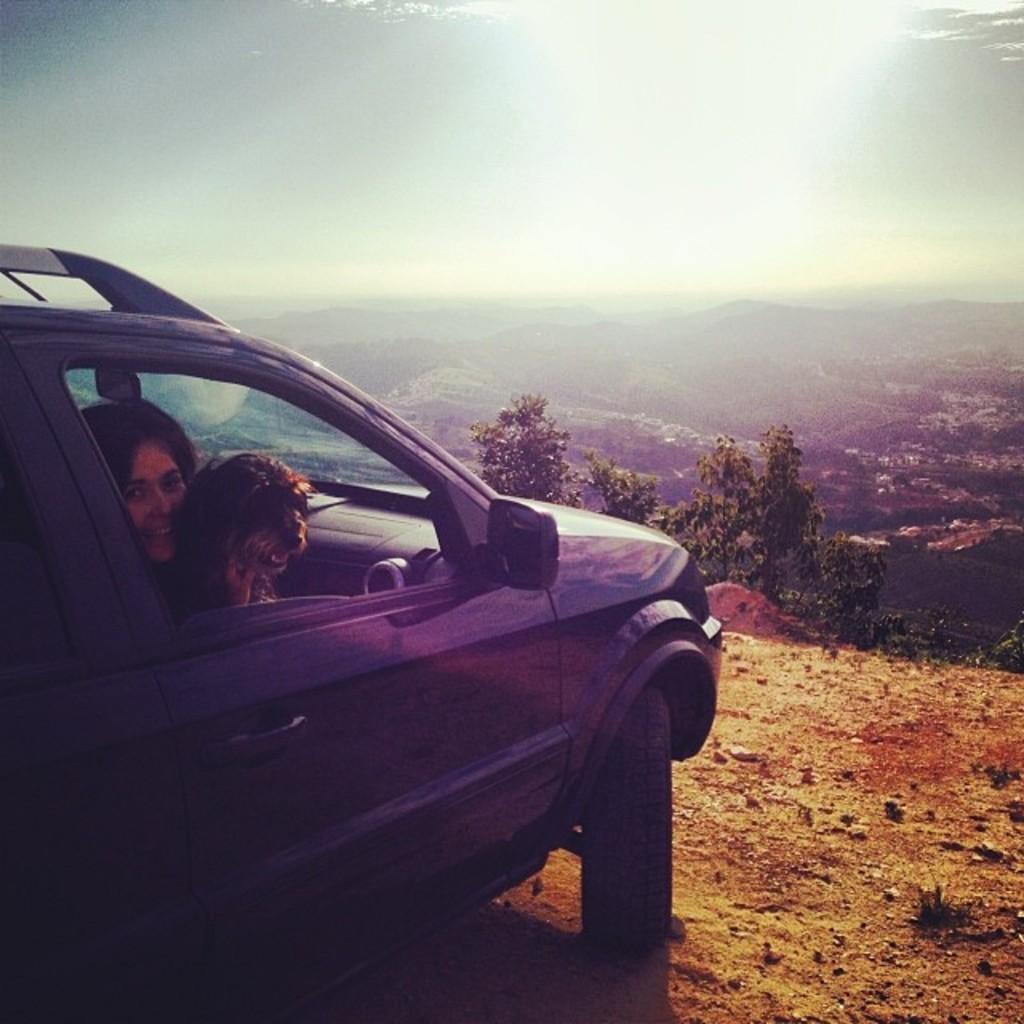Describe this image in one or two sentences. In this image there is a car on the hill. In the car there is a woman and dog sitting in the seat. At the top there is a sky. At the bottom there are hills and trees. 